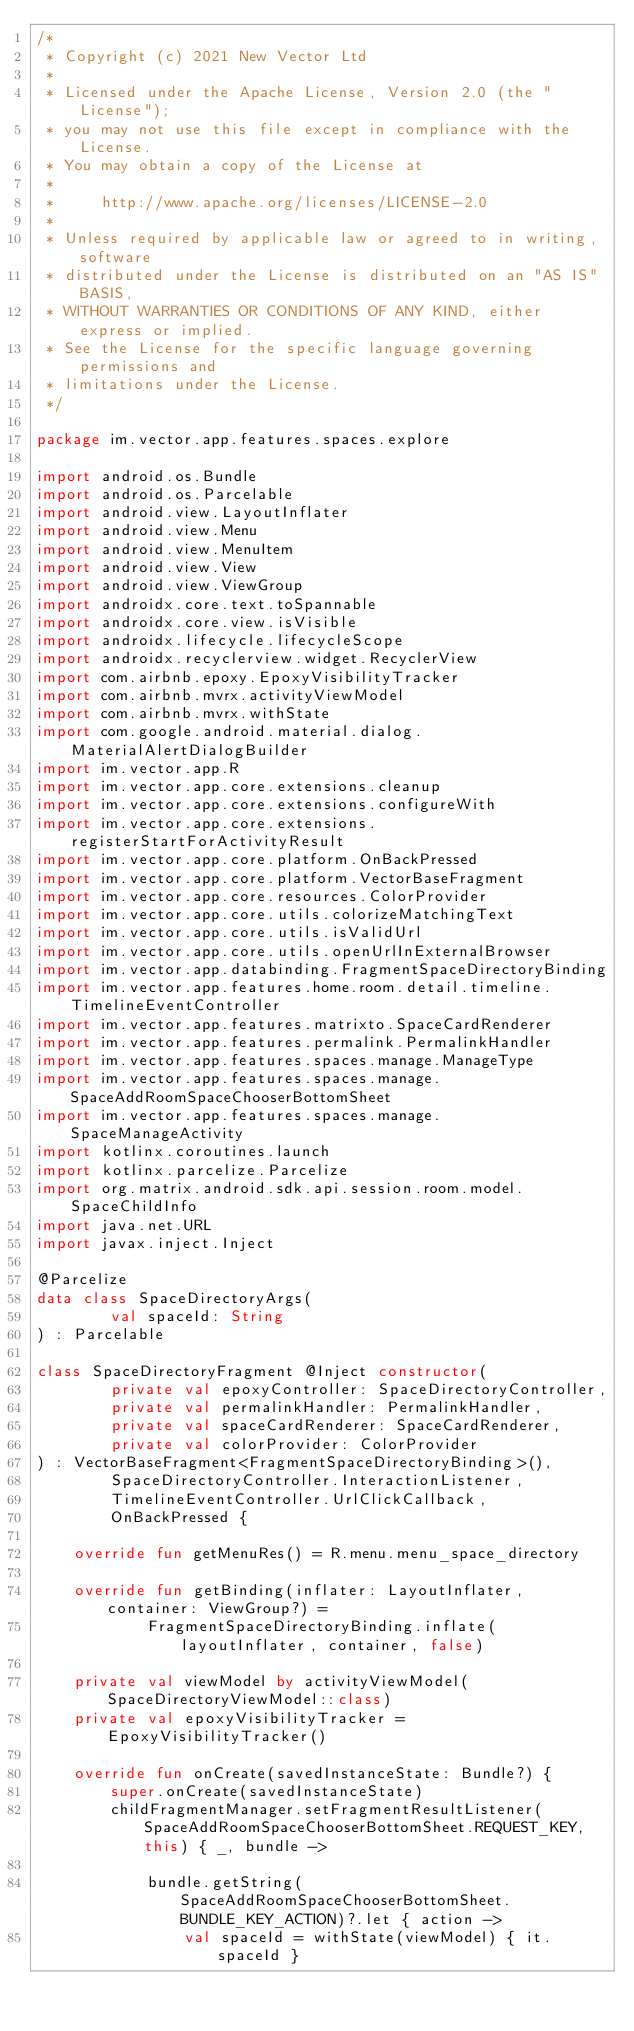Convert code to text. <code><loc_0><loc_0><loc_500><loc_500><_Kotlin_>/*
 * Copyright (c) 2021 New Vector Ltd
 *
 * Licensed under the Apache License, Version 2.0 (the "License");
 * you may not use this file except in compliance with the License.
 * You may obtain a copy of the License at
 *
 *     http://www.apache.org/licenses/LICENSE-2.0
 *
 * Unless required by applicable law or agreed to in writing, software
 * distributed under the License is distributed on an "AS IS" BASIS,
 * WITHOUT WARRANTIES OR CONDITIONS OF ANY KIND, either express or implied.
 * See the License for the specific language governing permissions and
 * limitations under the License.
 */

package im.vector.app.features.spaces.explore

import android.os.Bundle
import android.os.Parcelable
import android.view.LayoutInflater
import android.view.Menu
import android.view.MenuItem
import android.view.View
import android.view.ViewGroup
import androidx.core.text.toSpannable
import androidx.core.view.isVisible
import androidx.lifecycle.lifecycleScope
import androidx.recyclerview.widget.RecyclerView
import com.airbnb.epoxy.EpoxyVisibilityTracker
import com.airbnb.mvrx.activityViewModel
import com.airbnb.mvrx.withState
import com.google.android.material.dialog.MaterialAlertDialogBuilder
import im.vector.app.R
import im.vector.app.core.extensions.cleanup
import im.vector.app.core.extensions.configureWith
import im.vector.app.core.extensions.registerStartForActivityResult
import im.vector.app.core.platform.OnBackPressed
import im.vector.app.core.platform.VectorBaseFragment
import im.vector.app.core.resources.ColorProvider
import im.vector.app.core.utils.colorizeMatchingText
import im.vector.app.core.utils.isValidUrl
import im.vector.app.core.utils.openUrlInExternalBrowser
import im.vector.app.databinding.FragmentSpaceDirectoryBinding
import im.vector.app.features.home.room.detail.timeline.TimelineEventController
import im.vector.app.features.matrixto.SpaceCardRenderer
import im.vector.app.features.permalink.PermalinkHandler
import im.vector.app.features.spaces.manage.ManageType
import im.vector.app.features.spaces.manage.SpaceAddRoomSpaceChooserBottomSheet
import im.vector.app.features.spaces.manage.SpaceManageActivity
import kotlinx.coroutines.launch
import kotlinx.parcelize.Parcelize
import org.matrix.android.sdk.api.session.room.model.SpaceChildInfo
import java.net.URL
import javax.inject.Inject

@Parcelize
data class SpaceDirectoryArgs(
        val spaceId: String
) : Parcelable

class SpaceDirectoryFragment @Inject constructor(
        private val epoxyController: SpaceDirectoryController,
        private val permalinkHandler: PermalinkHandler,
        private val spaceCardRenderer: SpaceCardRenderer,
        private val colorProvider: ColorProvider
) : VectorBaseFragment<FragmentSpaceDirectoryBinding>(),
        SpaceDirectoryController.InteractionListener,
        TimelineEventController.UrlClickCallback,
        OnBackPressed {

    override fun getMenuRes() = R.menu.menu_space_directory

    override fun getBinding(inflater: LayoutInflater, container: ViewGroup?) =
            FragmentSpaceDirectoryBinding.inflate(layoutInflater, container, false)

    private val viewModel by activityViewModel(SpaceDirectoryViewModel::class)
    private val epoxyVisibilityTracker = EpoxyVisibilityTracker()

    override fun onCreate(savedInstanceState: Bundle?) {
        super.onCreate(savedInstanceState)
        childFragmentManager.setFragmentResultListener(SpaceAddRoomSpaceChooserBottomSheet.REQUEST_KEY, this) { _, bundle ->

            bundle.getString(SpaceAddRoomSpaceChooserBottomSheet.BUNDLE_KEY_ACTION)?.let { action ->
                val spaceId = withState(viewModel) { it.spaceId }</code> 